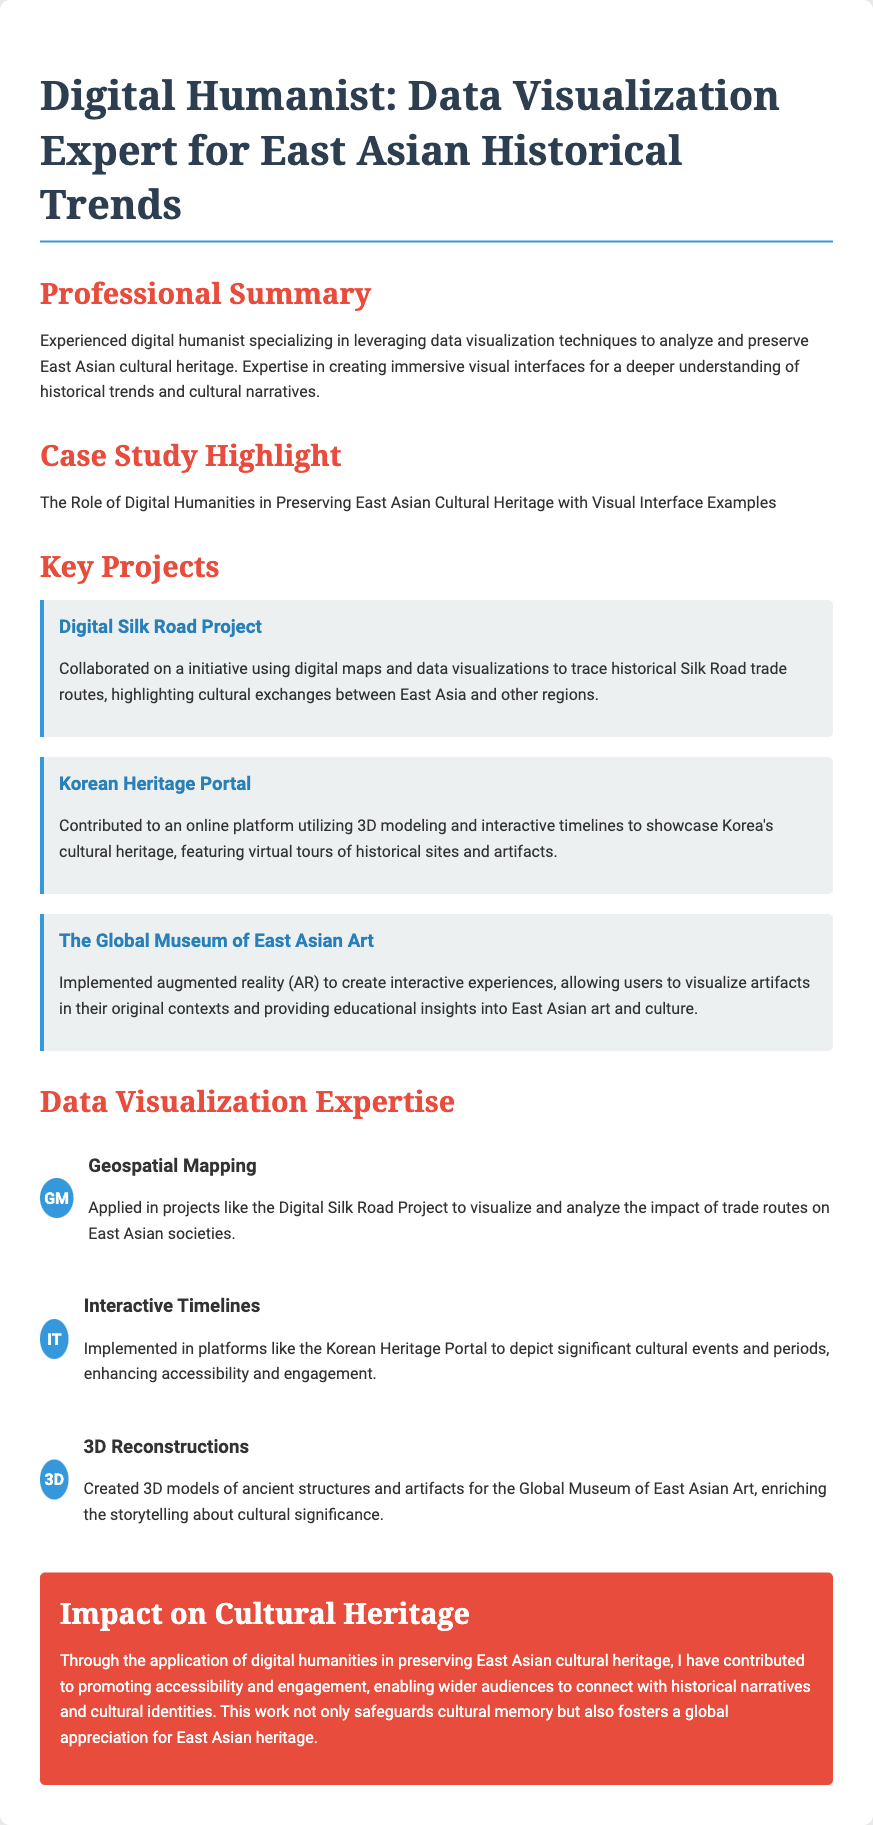What is the title of the resume? The title is presented prominently at the top of the document, summarizing the individual's professional focus.
Answer: Digital Humanist: Data Visualization Expert for East Asian Historical Trends What is the first key project mentioned? The document lists key projects, and the first one is highlighted under the Key Projects section.
Answer: Digital Silk Road Project Which technique is associated with the Korean Heritage Portal? The document describes techniques applied in various projects, including one specific to the Korean Heritage Portal.
Answer: Interactive Timelines What is one impact mentioned regarding cultural heritage? The impact section summarizes the effects of the individual's work on cultural heritage preservation and community engagement.
Answer: Promoting accessibility and engagement How many projects are listed under Key Projects? By counting the projects under the Key Projects section, the total number can be directly obtained.
Answer: Three 